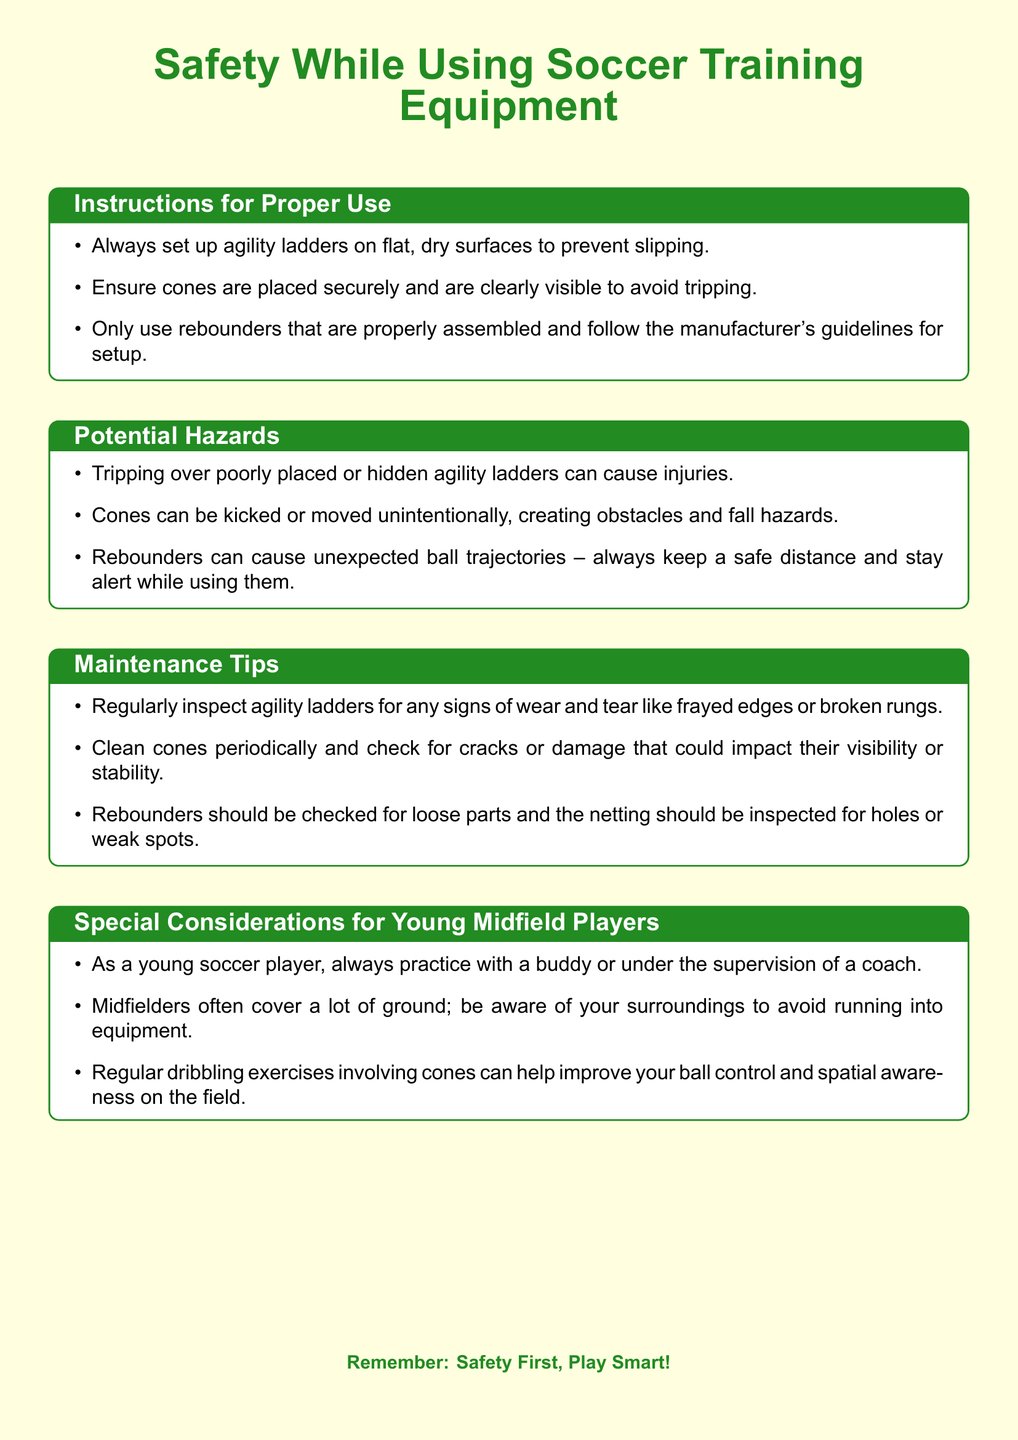What color should agility ladders be set on? Agility ladders should always be set up on flat, dry surfaces to prevent slipping, which implies that the surface should ideally be a specific color.
Answer: Not specified What should be checked on rebounders? Rebounders should be checked for loose parts and the netting inspected for holes or weak spots, highlighting what to look for during maintenance.
Answer: Loose parts, holes What is one potential hazard of using cones? Cones can be kicked or moved unintentionally, creating obstacles and fall hazards, which indicates a specific risk when training with them.
Answer: Obstacles What should young midfield players do when training? Young soccer players are advised to practice with a buddy or under the supervision of a coach for safety, which is a recommended practice.
Answer: Practice with a buddy What should be done regularly to agility ladders? Agility ladders should be regularly inspected for any signs of wear and tear like frayed edges or broken rungs to ensure safety while using them.
Answer: Inspected What should be ensured about cones? It should be ensured that cones are placed securely and are clearly visible to prevent tripping, which outlines a proper usage guideline.
Answer: Clearly visible 